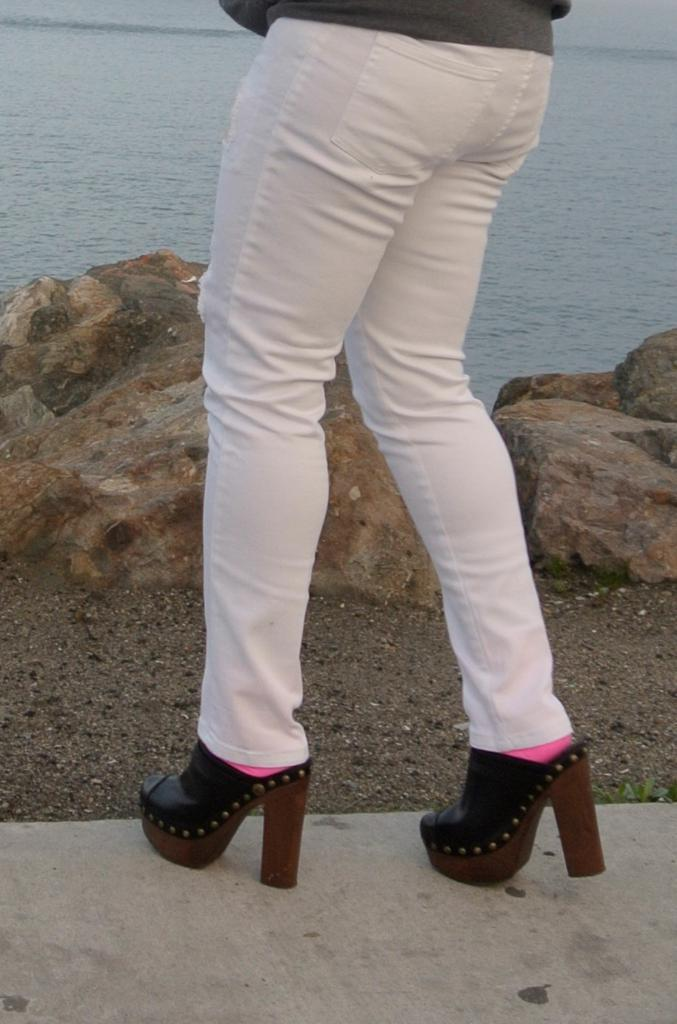Who is the main subject in the image? There is a girl in the image. What type of footwear is the girl wearing? The girl is wearing high heels. What is the girl doing in the image? The girl is walking on a road. What obstacle is in front of the girl? There are rocks in front of the girl. What natural feature can be seen in the image? The sea is visible in the image. What type of camp can be seen in the image? There is no camp present in the image. What stage of development is the girl in the image? The image does not provide information about the girl's stage of development. 